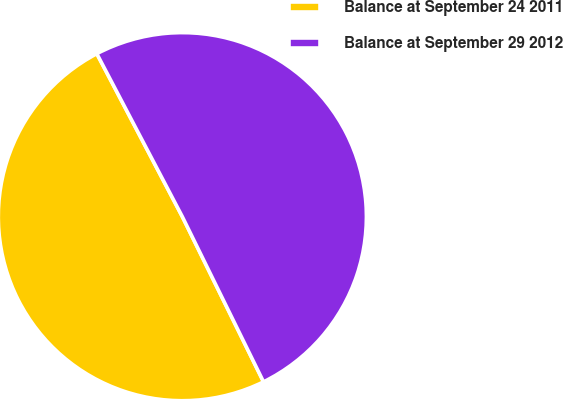<chart> <loc_0><loc_0><loc_500><loc_500><pie_chart><fcel>Balance at September 24 2011<fcel>Balance at September 29 2012<nl><fcel>49.58%<fcel>50.42%<nl></chart> 